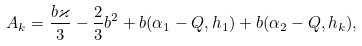Convert formula to latex. <formula><loc_0><loc_0><loc_500><loc_500>A _ { k } = \frac { b \varkappa } { 3 } - \frac { 2 } { 3 } b ^ { 2 } + b ( \alpha _ { 1 } - Q , h _ { 1 } ) + b ( \alpha _ { 2 } - Q , h _ { k } ) ,</formula> 